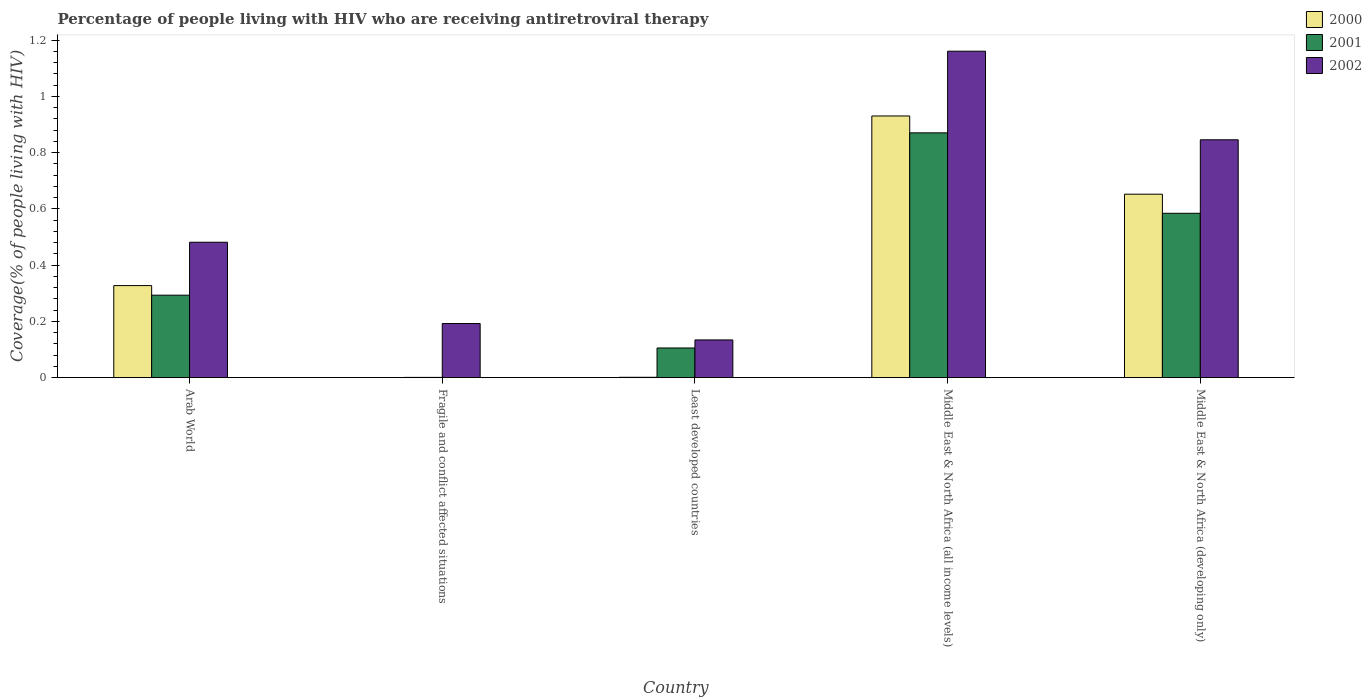How many groups of bars are there?
Your response must be concise. 5. How many bars are there on the 3rd tick from the right?
Ensure brevity in your answer.  3. What is the label of the 4th group of bars from the left?
Your response must be concise. Middle East & North Africa (all income levels). What is the percentage of the HIV infected people who are receiving antiretroviral therapy in 2002 in Middle East & North Africa (all income levels)?
Offer a terse response. 1.16. Across all countries, what is the maximum percentage of the HIV infected people who are receiving antiretroviral therapy in 2002?
Offer a terse response. 1.16. Across all countries, what is the minimum percentage of the HIV infected people who are receiving antiretroviral therapy in 2001?
Your response must be concise. 0. In which country was the percentage of the HIV infected people who are receiving antiretroviral therapy in 2001 maximum?
Offer a terse response. Middle East & North Africa (all income levels). In which country was the percentage of the HIV infected people who are receiving antiretroviral therapy in 2002 minimum?
Offer a terse response. Least developed countries. What is the total percentage of the HIV infected people who are receiving antiretroviral therapy in 2002 in the graph?
Offer a very short reply. 2.81. What is the difference between the percentage of the HIV infected people who are receiving antiretroviral therapy in 2001 in Arab World and that in Middle East & North Africa (developing only)?
Keep it short and to the point. -0.29. What is the difference between the percentage of the HIV infected people who are receiving antiretroviral therapy in 2001 in Middle East & North Africa (developing only) and the percentage of the HIV infected people who are receiving antiretroviral therapy in 2002 in Middle East & North Africa (all income levels)?
Provide a succinct answer. -0.58. What is the average percentage of the HIV infected people who are receiving antiretroviral therapy in 2002 per country?
Keep it short and to the point. 0.56. What is the difference between the percentage of the HIV infected people who are receiving antiretroviral therapy of/in 2000 and percentage of the HIV infected people who are receiving antiretroviral therapy of/in 2002 in Fragile and conflict affected situations?
Give a very brief answer. -0.19. What is the ratio of the percentage of the HIV infected people who are receiving antiretroviral therapy in 2001 in Arab World to that in Middle East & North Africa (developing only)?
Provide a short and direct response. 0.5. Is the percentage of the HIV infected people who are receiving antiretroviral therapy in 2002 in Fragile and conflict affected situations less than that in Least developed countries?
Your answer should be very brief. No. What is the difference between the highest and the second highest percentage of the HIV infected people who are receiving antiretroviral therapy in 2001?
Keep it short and to the point. 0.29. What is the difference between the highest and the lowest percentage of the HIV infected people who are receiving antiretroviral therapy in 2002?
Ensure brevity in your answer.  1.03. In how many countries, is the percentage of the HIV infected people who are receiving antiretroviral therapy in 2002 greater than the average percentage of the HIV infected people who are receiving antiretroviral therapy in 2002 taken over all countries?
Your response must be concise. 2. Is the sum of the percentage of the HIV infected people who are receiving antiretroviral therapy in 2002 in Arab World and Middle East & North Africa (developing only) greater than the maximum percentage of the HIV infected people who are receiving antiretroviral therapy in 2000 across all countries?
Offer a terse response. Yes. What does the 2nd bar from the left in Least developed countries represents?
Ensure brevity in your answer.  2001. What does the 1st bar from the right in Arab World represents?
Provide a succinct answer. 2002. How many bars are there?
Your response must be concise. 15. Are the values on the major ticks of Y-axis written in scientific E-notation?
Provide a short and direct response. No. Does the graph contain grids?
Keep it short and to the point. No. How are the legend labels stacked?
Give a very brief answer. Vertical. What is the title of the graph?
Provide a short and direct response. Percentage of people living with HIV who are receiving antiretroviral therapy. Does "2006" appear as one of the legend labels in the graph?
Offer a very short reply. No. What is the label or title of the X-axis?
Your answer should be compact. Country. What is the label or title of the Y-axis?
Give a very brief answer. Coverage(% of people living with HIV). What is the Coverage(% of people living with HIV) in 2000 in Arab World?
Offer a very short reply. 0.33. What is the Coverage(% of people living with HIV) in 2001 in Arab World?
Offer a very short reply. 0.29. What is the Coverage(% of people living with HIV) in 2002 in Arab World?
Offer a very short reply. 0.48. What is the Coverage(% of people living with HIV) of 2000 in Fragile and conflict affected situations?
Give a very brief answer. 0. What is the Coverage(% of people living with HIV) of 2001 in Fragile and conflict affected situations?
Provide a succinct answer. 0. What is the Coverage(% of people living with HIV) in 2002 in Fragile and conflict affected situations?
Offer a terse response. 0.19. What is the Coverage(% of people living with HIV) of 2000 in Least developed countries?
Offer a terse response. 0. What is the Coverage(% of people living with HIV) in 2001 in Least developed countries?
Provide a short and direct response. 0.11. What is the Coverage(% of people living with HIV) of 2002 in Least developed countries?
Your response must be concise. 0.13. What is the Coverage(% of people living with HIV) of 2000 in Middle East & North Africa (all income levels)?
Give a very brief answer. 0.93. What is the Coverage(% of people living with HIV) in 2001 in Middle East & North Africa (all income levels)?
Provide a succinct answer. 0.87. What is the Coverage(% of people living with HIV) of 2002 in Middle East & North Africa (all income levels)?
Your answer should be compact. 1.16. What is the Coverage(% of people living with HIV) of 2000 in Middle East & North Africa (developing only)?
Provide a succinct answer. 0.65. What is the Coverage(% of people living with HIV) of 2001 in Middle East & North Africa (developing only)?
Your response must be concise. 0.58. What is the Coverage(% of people living with HIV) of 2002 in Middle East & North Africa (developing only)?
Provide a succinct answer. 0.85. Across all countries, what is the maximum Coverage(% of people living with HIV) of 2000?
Ensure brevity in your answer.  0.93. Across all countries, what is the maximum Coverage(% of people living with HIV) of 2001?
Give a very brief answer. 0.87. Across all countries, what is the maximum Coverage(% of people living with HIV) in 2002?
Your response must be concise. 1.16. Across all countries, what is the minimum Coverage(% of people living with HIV) of 2000?
Your answer should be compact. 0. Across all countries, what is the minimum Coverage(% of people living with HIV) of 2001?
Your answer should be compact. 0. Across all countries, what is the minimum Coverage(% of people living with HIV) of 2002?
Provide a short and direct response. 0.13. What is the total Coverage(% of people living with HIV) in 2000 in the graph?
Give a very brief answer. 1.91. What is the total Coverage(% of people living with HIV) of 2001 in the graph?
Provide a short and direct response. 1.85. What is the total Coverage(% of people living with HIV) of 2002 in the graph?
Offer a very short reply. 2.81. What is the difference between the Coverage(% of people living with HIV) in 2000 in Arab World and that in Fragile and conflict affected situations?
Your answer should be compact. 0.33. What is the difference between the Coverage(% of people living with HIV) in 2001 in Arab World and that in Fragile and conflict affected situations?
Your response must be concise. 0.29. What is the difference between the Coverage(% of people living with HIV) in 2002 in Arab World and that in Fragile and conflict affected situations?
Offer a terse response. 0.29. What is the difference between the Coverage(% of people living with HIV) of 2000 in Arab World and that in Least developed countries?
Your response must be concise. 0.33. What is the difference between the Coverage(% of people living with HIV) of 2001 in Arab World and that in Least developed countries?
Offer a very short reply. 0.19. What is the difference between the Coverage(% of people living with HIV) in 2002 in Arab World and that in Least developed countries?
Give a very brief answer. 0.35. What is the difference between the Coverage(% of people living with HIV) of 2000 in Arab World and that in Middle East & North Africa (all income levels)?
Provide a succinct answer. -0.6. What is the difference between the Coverage(% of people living with HIV) in 2001 in Arab World and that in Middle East & North Africa (all income levels)?
Offer a terse response. -0.58. What is the difference between the Coverage(% of people living with HIV) in 2002 in Arab World and that in Middle East & North Africa (all income levels)?
Offer a terse response. -0.68. What is the difference between the Coverage(% of people living with HIV) of 2000 in Arab World and that in Middle East & North Africa (developing only)?
Give a very brief answer. -0.32. What is the difference between the Coverage(% of people living with HIV) in 2001 in Arab World and that in Middle East & North Africa (developing only)?
Provide a succinct answer. -0.29. What is the difference between the Coverage(% of people living with HIV) in 2002 in Arab World and that in Middle East & North Africa (developing only)?
Provide a short and direct response. -0.36. What is the difference between the Coverage(% of people living with HIV) of 2000 in Fragile and conflict affected situations and that in Least developed countries?
Offer a very short reply. -0. What is the difference between the Coverage(% of people living with HIV) of 2001 in Fragile and conflict affected situations and that in Least developed countries?
Provide a short and direct response. -0.1. What is the difference between the Coverage(% of people living with HIV) of 2002 in Fragile and conflict affected situations and that in Least developed countries?
Ensure brevity in your answer.  0.06. What is the difference between the Coverage(% of people living with HIV) of 2000 in Fragile and conflict affected situations and that in Middle East & North Africa (all income levels)?
Offer a terse response. -0.93. What is the difference between the Coverage(% of people living with HIV) of 2001 in Fragile and conflict affected situations and that in Middle East & North Africa (all income levels)?
Your answer should be compact. -0.87. What is the difference between the Coverage(% of people living with HIV) in 2002 in Fragile and conflict affected situations and that in Middle East & North Africa (all income levels)?
Give a very brief answer. -0.97. What is the difference between the Coverage(% of people living with HIV) of 2000 in Fragile and conflict affected situations and that in Middle East & North Africa (developing only)?
Your answer should be very brief. -0.65. What is the difference between the Coverage(% of people living with HIV) in 2001 in Fragile and conflict affected situations and that in Middle East & North Africa (developing only)?
Provide a succinct answer. -0.58. What is the difference between the Coverage(% of people living with HIV) in 2002 in Fragile and conflict affected situations and that in Middle East & North Africa (developing only)?
Provide a short and direct response. -0.65. What is the difference between the Coverage(% of people living with HIV) of 2000 in Least developed countries and that in Middle East & North Africa (all income levels)?
Make the answer very short. -0.93. What is the difference between the Coverage(% of people living with HIV) in 2001 in Least developed countries and that in Middle East & North Africa (all income levels)?
Your response must be concise. -0.76. What is the difference between the Coverage(% of people living with HIV) of 2002 in Least developed countries and that in Middle East & North Africa (all income levels)?
Make the answer very short. -1.03. What is the difference between the Coverage(% of people living with HIV) of 2000 in Least developed countries and that in Middle East & North Africa (developing only)?
Provide a short and direct response. -0.65. What is the difference between the Coverage(% of people living with HIV) in 2001 in Least developed countries and that in Middle East & North Africa (developing only)?
Your answer should be compact. -0.48. What is the difference between the Coverage(% of people living with HIV) of 2002 in Least developed countries and that in Middle East & North Africa (developing only)?
Give a very brief answer. -0.71. What is the difference between the Coverage(% of people living with HIV) of 2000 in Middle East & North Africa (all income levels) and that in Middle East & North Africa (developing only)?
Your answer should be very brief. 0.28. What is the difference between the Coverage(% of people living with HIV) of 2001 in Middle East & North Africa (all income levels) and that in Middle East & North Africa (developing only)?
Ensure brevity in your answer.  0.29. What is the difference between the Coverage(% of people living with HIV) in 2002 in Middle East & North Africa (all income levels) and that in Middle East & North Africa (developing only)?
Ensure brevity in your answer.  0.31. What is the difference between the Coverage(% of people living with HIV) of 2000 in Arab World and the Coverage(% of people living with HIV) of 2001 in Fragile and conflict affected situations?
Offer a very short reply. 0.33. What is the difference between the Coverage(% of people living with HIV) of 2000 in Arab World and the Coverage(% of people living with HIV) of 2002 in Fragile and conflict affected situations?
Provide a short and direct response. 0.13. What is the difference between the Coverage(% of people living with HIV) in 2001 in Arab World and the Coverage(% of people living with HIV) in 2002 in Fragile and conflict affected situations?
Offer a terse response. 0.1. What is the difference between the Coverage(% of people living with HIV) in 2000 in Arab World and the Coverage(% of people living with HIV) in 2001 in Least developed countries?
Give a very brief answer. 0.22. What is the difference between the Coverage(% of people living with HIV) in 2000 in Arab World and the Coverage(% of people living with HIV) in 2002 in Least developed countries?
Provide a short and direct response. 0.19. What is the difference between the Coverage(% of people living with HIV) of 2001 in Arab World and the Coverage(% of people living with HIV) of 2002 in Least developed countries?
Your answer should be very brief. 0.16. What is the difference between the Coverage(% of people living with HIV) in 2000 in Arab World and the Coverage(% of people living with HIV) in 2001 in Middle East & North Africa (all income levels)?
Your answer should be compact. -0.54. What is the difference between the Coverage(% of people living with HIV) of 2000 in Arab World and the Coverage(% of people living with HIV) of 2002 in Middle East & North Africa (all income levels)?
Your answer should be compact. -0.83. What is the difference between the Coverage(% of people living with HIV) of 2001 in Arab World and the Coverage(% of people living with HIV) of 2002 in Middle East & North Africa (all income levels)?
Provide a short and direct response. -0.87. What is the difference between the Coverage(% of people living with HIV) in 2000 in Arab World and the Coverage(% of people living with HIV) in 2001 in Middle East & North Africa (developing only)?
Provide a short and direct response. -0.26. What is the difference between the Coverage(% of people living with HIV) of 2000 in Arab World and the Coverage(% of people living with HIV) of 2002 in Middle East & North Africa (developing only)?
Your answer should be compact. -0.52. What is the difference between the Coverage(% of people living with HIV) in 2001 in Arab World and the Coverage(% of people living with HIV) in 2002 in Middle East & North Africa (developing only)?
Make the answer very short. -0.55. What is the difference between the Coverage(% of people living with HIV) of 2000 in Fragile and conflict affected situations and the Coverage(% of people living with HIV) of 2001 in Least developed countries?
Your response must be concise. -0.1. What is the difference between the Coverage(% of people living with HIV) of 2000 in Fragile and conflict affected situations and the Coverage(% of people living with HIV) of 2002 in Least developed countries?
Offer a very short reply. -0.13. What is the difference between the Coverage(% of people living with HIV) in 2001 in Fragile and conflict affected situations and the Coverage(% of people living with HIV) in 2002 in Least developed countries?
Your answer should be very brief. -0.13. What is the difference between the Coverage(% of people living with HIV) of 2000 in Fragile and conflict affected situations and the Coverage(% of people living with HIV) of 2001 in Middle East & North Africa (all income levels)?
Give a very brief answer. -0.87. What is the difference between the Coverage(% of people living with HIV) of 2000 in Fragile and conflict affected situations and the Coverage(% of people living with HIV) of 2002 in Middle East & North Africa (all income levels)?
Make the answer very short. -1.16. What is the difference between the Coverage(% of people living with HIV) of 2001 in Fragile and conflict affected situations and the Coverage(% of people living with HIV) of 2002 in Middle East & North Africa (all income levels)?
Provide a succinct answer. -1.16. What is the difference between the Coverage(% of people living with HIV) in 2000 in Fragile and conflict affected situations and the Coverage(% of people living with HIV) in 2001 in Middle East & North Africa (developing only)?
Provide a succinct answer. -0.58. What is the difference between the Coverage(% of people living with HIV) in 2000 in Fragile and conflict affected situations and the Coverage(% of people living with HIV) in 2002 in Middle East & North Africa (developing only)?
Keep it short and to the point. -0.85. What is the difference between the Coverage(% of people living with HIV) in 2001 in Fragile and conflict affected situations and the Coverage(% of people living with HIV) in 2002 in Middle East & North Africa (developing only)?
Provide a short and direct response. -0.84. What is the difference between the Coverage(% of people living with HIV) of 2000 in Least developed countries and the Coverage(% of people living with HIV) of 2001 in Middle East & North Africa (all income levels)?
Offer a very short reply. -0.87. What is the difference between the Coverage(% of people living with HIV) of 2000 in Least developed countries and the Coverage(% of people living with HIV) of 2002 in Middle East & North Africa (all income levels)?
Make the answer very short. -1.16. What is the difference between the Coverage(% of people living with HIV) of 2001 in Least developed countries and the Coverage(% of people living with HIV) of 2002 in Middle East & North Africa (all income levels)?
Offer a terse response. -1.05. What is the difference between the Coverage(% of people living with HIV) of 2000 in Least developed countries and the Coverage(% of people living with HIV) of 2001 in Middle East & North Africa (developing only)?
Give a very brief answer. -0.58. What is the difference between the Coverage(% of people living with HIV) in 2000 in Least developed countries and the Coverage(% of people living with HIV) in 2002 in Middle East & North Africa (developing only)?
Your answer should be very brief. -0.84. What is the difference between the Coverage(% of people living with HIV) in 2001 in Least developed countries and the Coverage(% of people living with HIV) in 2002 in Middle East & North Africa (developing only)?
Give a very brief answer. -0.74. What is the difference between the Coverage(% of people living with HIV) of 2000 in Middle East & North Africa (all income levels) and the Coverage(% of people living with HIV) of 2001 in Middle East & North Africa (developing only)?
Your answer should be compact. 0.35. What is the difference between the Coverage(% of people living with HIV) in 2000 in Middle East & North Africa (all income levels) and the Coverage(% of people living with HIV) in 2002 in Middle East & North Africa (developing only)?
Your answer should be very brief. 0.08. What is the difference between the Coverage(% of people living with HIV) of 2001 in Middle East & North Africa (all income levels) and the Coverage(% of people living with HIV) of 2002 in Middle East & North Africa (developing only)?
Your response must be concise. 0.02. What is the average Coverage(% of people living with HIV) in 2000 per country?
Make the answer very short. 0.38. What is the average Coverage(% of people living with HIV) in 2001 per country?
Provide a short and direct response. 0.37. What is the average Coverage(% of people living with HIV) of 2002 per country?
Provide a short and direct response. 0.56. What is the difference between the Coverage(% of people living with HIV) of 2000 and Coverage(% of people living with HIV) of 2001 in Arab World?
Your answer should be compact. 0.03. What is the difference between the Coverage(% of people living with HIV) in 2000 and Coverage(% of people living with HIV) in 2002 in Arab World?
Offer a terse response. -0.15. What is the difference between the Coverage(% of people living with HIV) in 2001 and Coverage(% of people living with HIV) in 2002 in Arab World?
Provide a succinct answer. -0.19. What is the difference between the Coverage(% of people living with HIV) of 2000 and Coverage(% of people living with HIV) of 2001 in Fragile and conflict affected situations?
Your response must be concise. -0. What is the difference between the Coverage(% of people living with HIV) in 2000 and Coverage(% of people living with HIV) in 2002 in Fragile and conflict affected situations?
Ensure brevity in your answer.  -0.19. What is the difference between the Coverage(% of people living with HIV) in 2001 and Coverage(% of people living with HIV) in 2002 in Fragile and conflict affected situations?
Provide a short and direct response. -0.19. What is the difference between the Coverage(% of people living with HIV) of 2000 and Coverage(% of people living with HIV) of 2001 in Least developed countries?
Your answer should be very brief. -0.1. What is the difference between the Coverage(% of people living with HIV) of 2000 and Coverage(% of people living with HIV) of 2002 in Least developed countries?
Offer a very short reply. -0.13. What is the difference between the Coverage(% of people living with HIV) in 2001 and Coverage(% of people living with HIV) in 2002 in Least developed countries?
Your answer should be very brief. -0.03. What is the difference between the Coverage(% of people living with HIV) of 2000 and Coverage(% of people living with HIV) of 2002 in Middle East & North Africa (all income levels)?
Keep it short and to the point. -0.23. What is the difference between the Coverage(% of people living with HIV) of 2001 and Coverage(% of people living with HIV) of 2002 in Middle East & North Africa (all income levels)?
Give a very brief answer. -0.29. What is the difference between the Coverage(% of people living with HIV) in 2000 and Coverage(% of people living with HIV) in 2001 in Middle East & North Africa (developing only)?
Provide a succinct answer. 0.07. What is the difference between the Coverage(% of people living with HIV) in 2000 and Coverage(% of people living with HIV) in 2002 in Middle East & North Africa (developing only)?
Provide a succinct answer. -0.19. What is the difference between the Coverage(% of people living with HIV) of 2001 and Coverage(% of people living with HIV) of 2002 in Middle East & North Africa (developing only)?
Make the answer very short. -0.26. What is the ratio of the Coverage(% of people living with HIV) in 2000 in Arab World to that in Fragile and conflict affected situations?
Offer a very short reply. 679.72. What is the ratio of the Coverage(% of people living with HIV) in 2001 in Arab World to that in Fragile and conflict affected situations?
Offer a terse response. 310.29. What is the ratio of the Coverage(% of people living with HIV) of 2002 in Arab World to that in Fragile and conflict affected situations?
Offer a terse response. 2.5. What is the ratio of the Coverage(% of people living with HIV) in 2000 in Arab World to that in Least developed countries?
Your response must be concise. 245.99. What is the ratio of the Coverage(% of people living with HIV) in 2001 in Arab World to that in Least developed countries?
Make the answer very short. 2.78. What is the ratio of the Coverage(% of people living with HIV) in 2002 in Arab World to that in Least developed countries?
Your response must be concise. 3.59. What is the ratio of the Coverage(% of people living with HIV) in 2000 in Arab World to that in Middle East & North Africa (all income levels)?
Provide a short and direct response. 0.35. What is the ratio of the Coverage(% of people living with HIV) of 2001 in Arab World to that in Middle East & North Africa (all income levels)?
Ensure brevity in your answer.  0.34. What is the ratio of the Coverage(% of people living with HIV) of 2002 in Arab World to that in Middle East & North Africa (all income levels)?
Offer a terse response. 0.41. What is the ratio of the Coverage(% of people living with HIV) of 2000 in Arab World to that in Middle East & North Africa (developing only)?
Give a very brief answer. 0.5. What is the ratio of the Coverage(% of people living with HIV) in 2001 in Arab World to that in Middle East & North Africa (developing only)?
Your response must be concise. 0.5. What is the ratio of the Coverage(% of people living with HIV) in 2002 in Arab World to that in Middle East & North Africa (developing only)?
Make the answer very short. 0.57. What is the ratio of the Coverage(% of people living with HIV) in 2000 in Fragile and conflict affected situations to that in Least developed countries?
Offer a very short reply. 0.36. What is the ratio of the Coverage(% of people living with HIV) in 2001 in Fragile and conflict affected situations to that in Least developed countries?
Offer a terse response. 0.01. What is the ratio of the Coverage(% of people living with HIV) of 2002 in Fragile and conflict affected situations to that in Least developed countries?
Offer a terse response. 1.43. What is the ratio of the Coverage(% of people living with HIV) of 2001 in Fragile and conflict affected situations to that in Middle East & North Africa (all income levels)?
Offer a terse response. 0. What is the ratio of the Coverage(% of people living with HIV) in 2002 in Fragile and conflict affected situations to that in Middle East & North Africa (all income levels)?
Keep it short and to the point. 0.17. What is the ratio of the Coverage(% of people living with HIV) of 2000 in Fragile and conflict affected situations to that in Middle East & North Africa (developing only)?
Your response must be concise. 0. What is the ratio of the Coverage(% of people living with HIV) in 2001 in Fragile and conflict affected situations to that in Middle East & North Africa (developing only)?
Offer a very short reply. 0. What is the ratio of the Coverage(% of people living with HIV) in 2002 in Fragile and conflict affected situations to that in Middle East & North Africa (developing only)?
Offer a terse response. 0.23. What is the ratio of the Coverage(% of people living with HIV) in 2000 in Least developed countries to that in Middle East & North Africa (all income levels)?
Your answer should be compact. 0. What is the ratio of the Coverage(% of people living with HIV) in 2001 in Least developed countries to that in Middle East & North Africa (all income levels)?
Your answer should be very brief. 0.12. What is the ratio of the Coverage(% of people living with HIV) in 2002 in Least developed countries to that in Middle East & North Africa (all income levels)?
Make the answer very short. 0.12. What is the ratio of the Coverage(% of people living with HIV) of 2000 in Least developed countries to that in Middle East & North Africa (developing only)?
Keep it short and to the point. 0. What is the ratio of the Coverage(% of people living with HIV) in 2001 in Least developed countries to that in Middle East & North Africa (developing only)?
Offer a terse response. 0.18. What is the ratio of the Coverage(% of people living with HIV) in 2002 in Least developed countries to that in Middle East & North Africa (developing only)?
Provide a succinct answer. 0.16. What is the ratio of the Coverage(% of people living with HIV) in 2000 in Middle East & North Africa (all income levels) to that in Middle East & North Africa (developing only)?
Ensure brevity in your answer.  1.43. What is the ratio of the Coverage(% of people living with HIV) of 2001 in Middle East & North Africa (all income levels) to that in Middle East & North Africa (developing only)?
Keep it short and to the point. 1.49. What is the ratio of the Coverage(% of people living with HIV) of 2002 in Middle East & North Africa (all income levels) to that in Middle East & North Africa (developing only)?
Provide a short and direct response. 1.37. What is the difference between the highest and the second highest Coverage(% of people living with HIV) of 2000?
Give a very brief answer. 0.28. What is the difference between the highest and the second highest Coverage(% of people living with HIV) of 2001?
Your response must be concise. 0.29. What is the difference between the highest and the second highest Coverage(% of people living with HIV) in 2002?
Ensure brevity in your answer.  0.31. What is the difference between the highest and the lowest Coverage(% of people living with HIV) of 2000?
Provide a succinct answer. 0.93. What is the difference between the highest and the lowest Coverage(% of people living with HIV) in 2001?
Keep it short and to the point. 0.87. What is the difference between the highest and the lowest Coverage(% of people living with HIV) of 2002?
Keep it short and to the point. 1.03. 